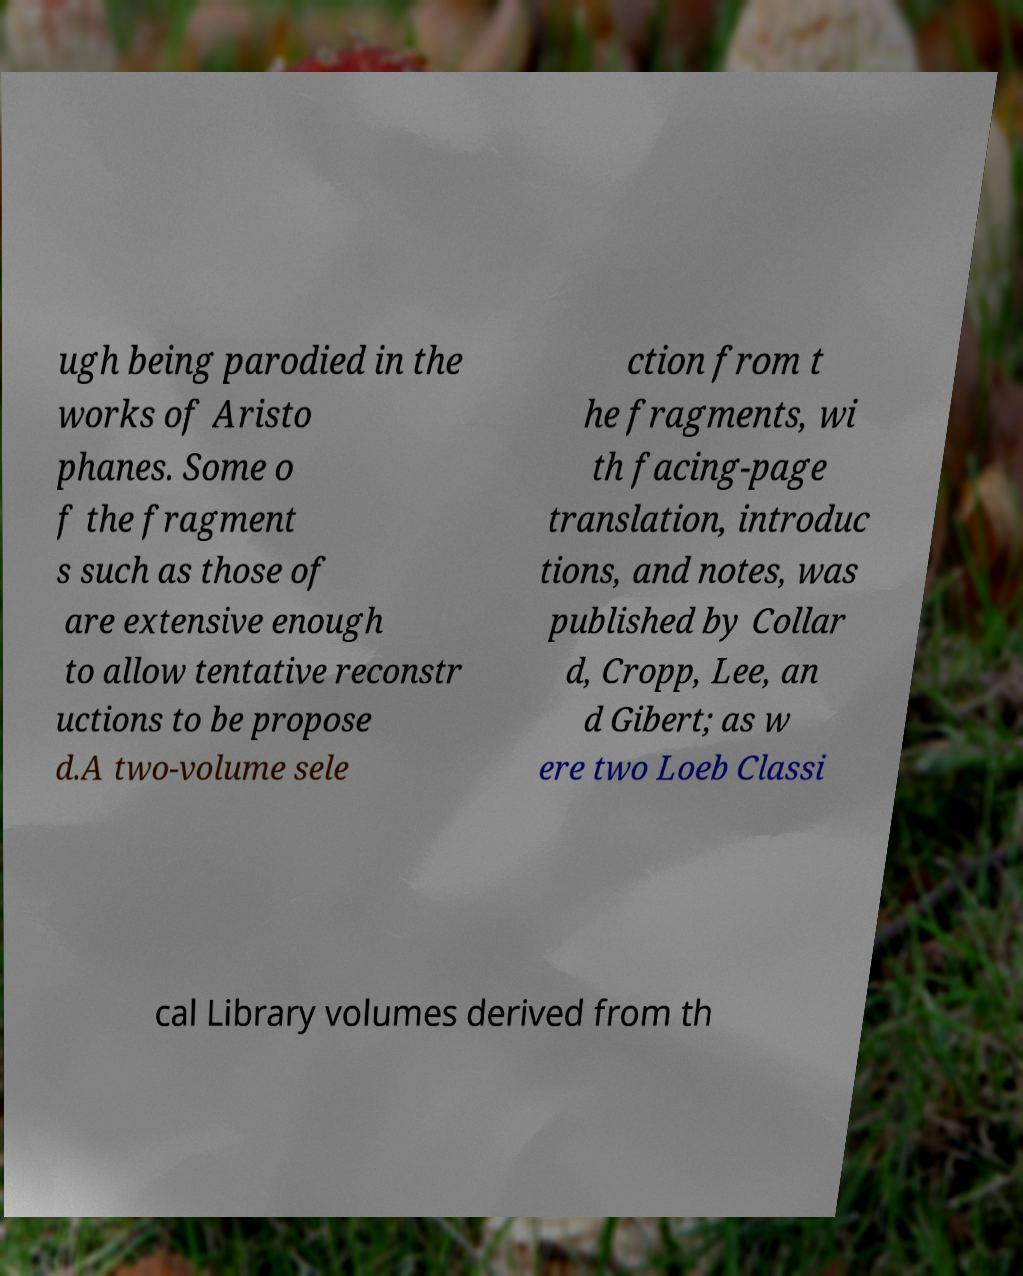Please read and relay the text visible in this image. What does it say? ugh being parodied in the works of Aristo phanes. Some o f the fragment s such as those of are extensive enough to allow tentative reconstr uctions to be propose d.A two-volume sele ction from t he fragments, wi th facing-page translation, introduc tions, and notes, was published by Collar d, Cropp, Lee, an d Gibert; as w ere two Loeb Classi cal Library volumes derived from th 